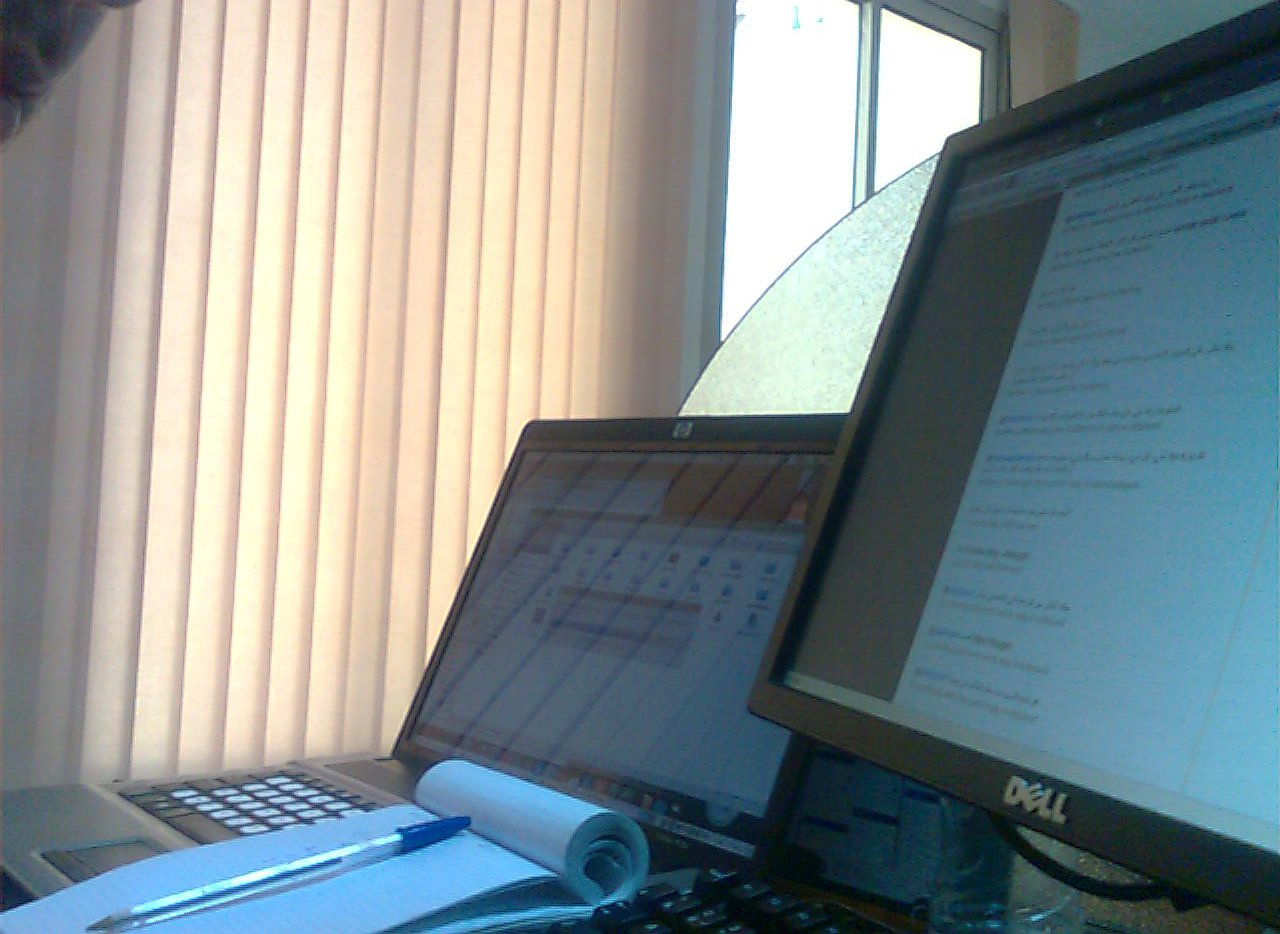What is the pen on? The pen is placed on a notepad, likely used for jotting down quick notes or ideas during work. 